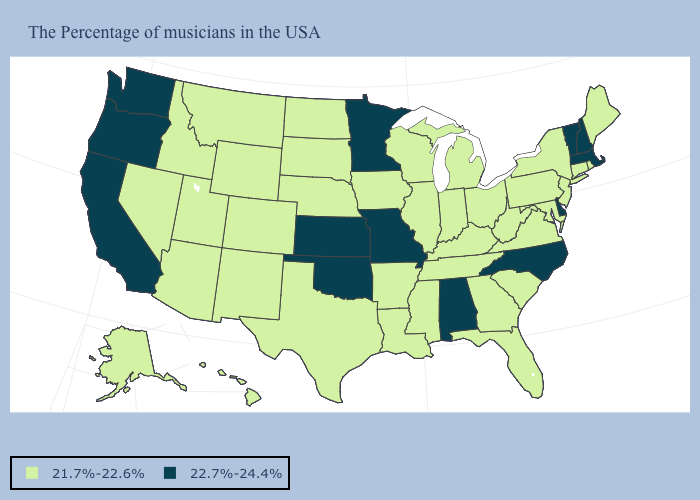What is the highest value in the MidWest ?
Answer briefly. 22.7%-24.4%. Which states have the highest value in the USA?
Quick response, please. Massachusetts, New Hampshire, Vermont, Delaware, North Carolina, Alabama, Missouri, Minnesota, Kansas, Oklahoma, California, Washington, Oregon. Name the states that have a value in the range 21.7%-22.6%?
Write a very short answer. Maine, Rhode Island, Connecticut, New York, New Jersey, Maryland, Pennsylvania, Virginia, South Carolina, West Virginia, Ohio, Florida, Georgia, Michigan, Kentucky, Indiana, Tennessee, Wisconsin, Illinois, Mississippi, Louisiana, Arkansas, Iowa, Nebraska, Texas, South Dakota, North Dakota, Wyoming, Colorado, New Mexico, Utah, Montana, Arizona, Idaho, Nevada, Alaska, Hawaii. What is the lowest value in the USA?
Be succinct. 21.7%-22.6%. Does Utah have the same value as South Carolina?
Give a very brief answer. Yes. Name the states that have a value in the range 21.7%-22.6%?
Answer briefly. Maine, Rhode Island, Connecticut, New York, New Jersey, Maryland, Pennsylvania, Virginia, South Carolina, West Virginia, Ohio, Florida, Georgia, Michigan, Kentucky, Indiana, Tennessee, Wisconsin, Illinois, Mississippi, Louisiana, Arkansas, Iowa, Nebraska, Texas, South Dakota, North Dakota, Wyoming, Colorado, New Mexico, Utah, Montana, Arizona, Idaho, Nevada, Alaska, Hawaii. Name the states that have a value in the range 21.7%-22.6%?
Answer briefly. Maine, Rhode Island, Connecticut, New York, New Jersey, Maryland, Pennsylvania, Virginia, South Carolina, West Virginia, Ohio, Florida, Georgia, Michigan, Kentucky, Indiana, Tennessee, Wisconsin, Illinois, Mississippi, Louisiana, Arkansas, Iowa, Nebraska, Texas, South Dakota, North Dakota, Wyoming, Colorado, New Mexico, Utah, Montana, Arizona, Idaho, Nevada, Alaska, Hawaii. Does Kansas have the highest value in the USA?
Be succinct. Yes. What is the value of New Mexico?
Answer briefly. 21.7%-22.6%. Does the first symbol in the legend represent the smallest category?
Keep it brief. Yes. Among the states that border Maryland , which have the highest value?
Be succinct. Delaware. Name the states that have a value in the range 21.7%-22.6%?
Answer briefly. Maine, Rhode Island, Connecticut, New York, New Jersey, Maryland, Pennsylvania, Virginia, South Carolina, West Virginia, Ohio, Florida, Georgia, Michigan, Kentucky, Indiana, Tennessee, Wisconsin, Illinois, Mississippi, Louisiana, Arkansas, Iowa, Nebraska, Texas, South Dakota, North Dakota, Wyoming, Colorado, New Mexico, Utah, Montana, Arizona, Idaho, Nevada, Alaska, Hawaii. How many symbols are there in the legend?
Short answer required. 2. What is the value of New Hampshire?
Answer briefly. 22.7%-24.4%. Does Nevada have the highest value in the West?
Short answer required. No. 